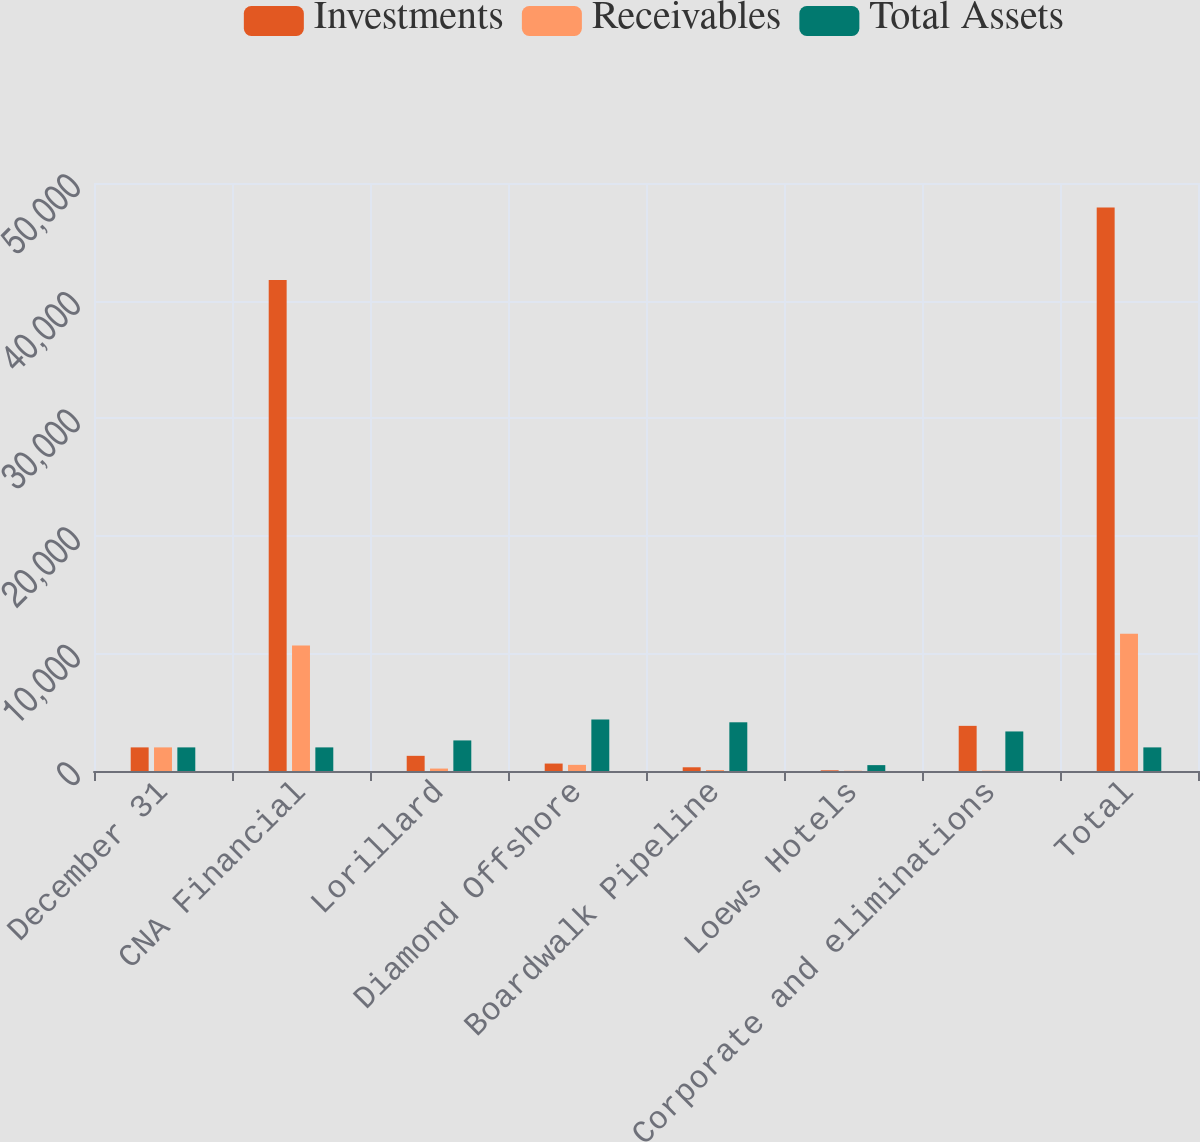Convert chart. <chart><loc_0><loc_0><loc_500><loc_500><stacked_bar_chart><ecel><fcel>December 31<fcel>CNA Financial<fcel>Lorillard<fcel>Diamond Offshore<fcel>Boardwalk Pipeline<fcel>Loews Hotels<fcel>Corporate and eliminations<fcel>Total<nl><fcel>Investments<fcel>2007<fcel>41762<fcel>1290<fcel>633<fcel>316<fcel>58<fcel>3839<fcel>47923<nl><fcel>Receivables<fcel>2007<fcel>10672<fcel>208<fcel>523<fcel>87<fcel>22<fcel>29<fcel>11677<nl><fcel>Total Assets<fcel>2007<fcel>2007<fcel>2600<fcel>4371<fcel>4142<fcel>499<fcel>3363<fcel>2007<nl></chart> 